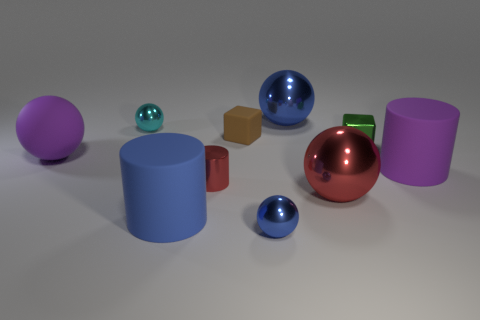Is the material of the blue cylinder the same as the tiny cube right of the brown cube?
Offer a terse response. No. There is a large metal ball in front of the blue ball that is to the right of the blue metal ball in front of the big red object; what is its color?
Provide a short and direct response. Red. What material is the red object that is the same size as the green thing?
Offer a terse response. Metal. How many red cylinders have the same material as the green object?
Offer a terse response. 1. Does the purple matte object to the right of the red metal cylinder have the same size as the blue thing that is in front of the big blue matte object?
Your answer should be compact. No. There is a matte cylinder that is behind the big blue matte cylinder; what color is it?
Your response must be concise. Purple. What is the material of the sphere that is the same color as the small shiny cylinder?
Make the answer very short. Metal. How many other tiny balls are the same color as the matte ball?
Your answer should be very brief. 0. There is a red metal cylinder; does it have the same size as the rubber cylinder that is left of the small brown matte thing?
Provide a short and direct response. No. There is a cube that is on the left side of the blue ball behind the large rubber cylinder right of the small matte block; what is its size?
Give a very brief answer. Small. 